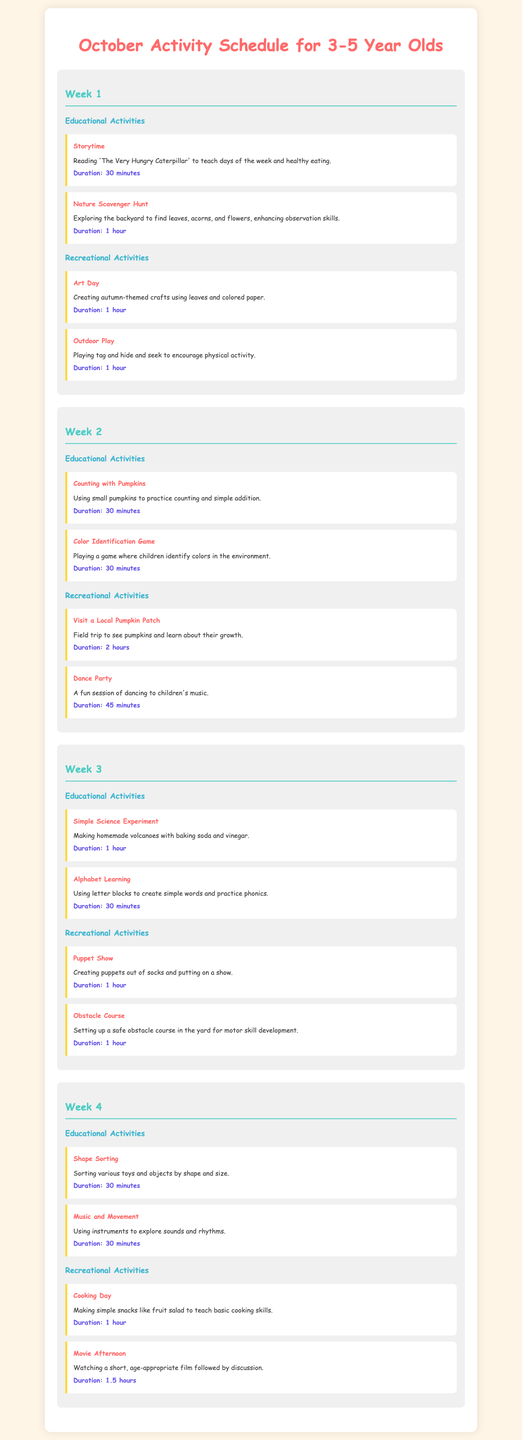what is the title of the document? The title appears prominently at the top of the document and provides a clear overview of the content.
Answer: October Activity Schedule for 3-5 Year Olds how many weeks are included in the schedule? The document is divided into four distinct sections, each representing a week of activities.
Answer: 4 what activity is scheduled for outdoor play in Week 1? The document lists specific activities under each week, with outdoor play clearly identified.
Answer: Playing tag and hide and seek which activity involves making homemade volcanoes? The educational section of Week 3 includes this specific hands-on experiment.
Answer: Simple Science Experiment how long is the duration for the Dance Party? Each activity lists a specific duration in minutes for proper time management.
Answer: 45 minutes what is the theme of the crafts in Week 1? The document specifies the type of crafts being created during the art activity of Week 1 for clarity.
Answer: autumn-themed crafts which educational activity involves music in Week 4? The document describes activities that incorporate various themes, including music, in this specific week.
Answer: Music and Movement what is the total duration of activities in Week 2? By summing the durations of all activities listed for Week 2, this question tests the ability to aggregate information.
Answer: 3 hours which local location is visited during Week 2 activities? The document specifies a field trip destination in the recreational section of Week 2.
Answer: Local Pumpkin Patch 